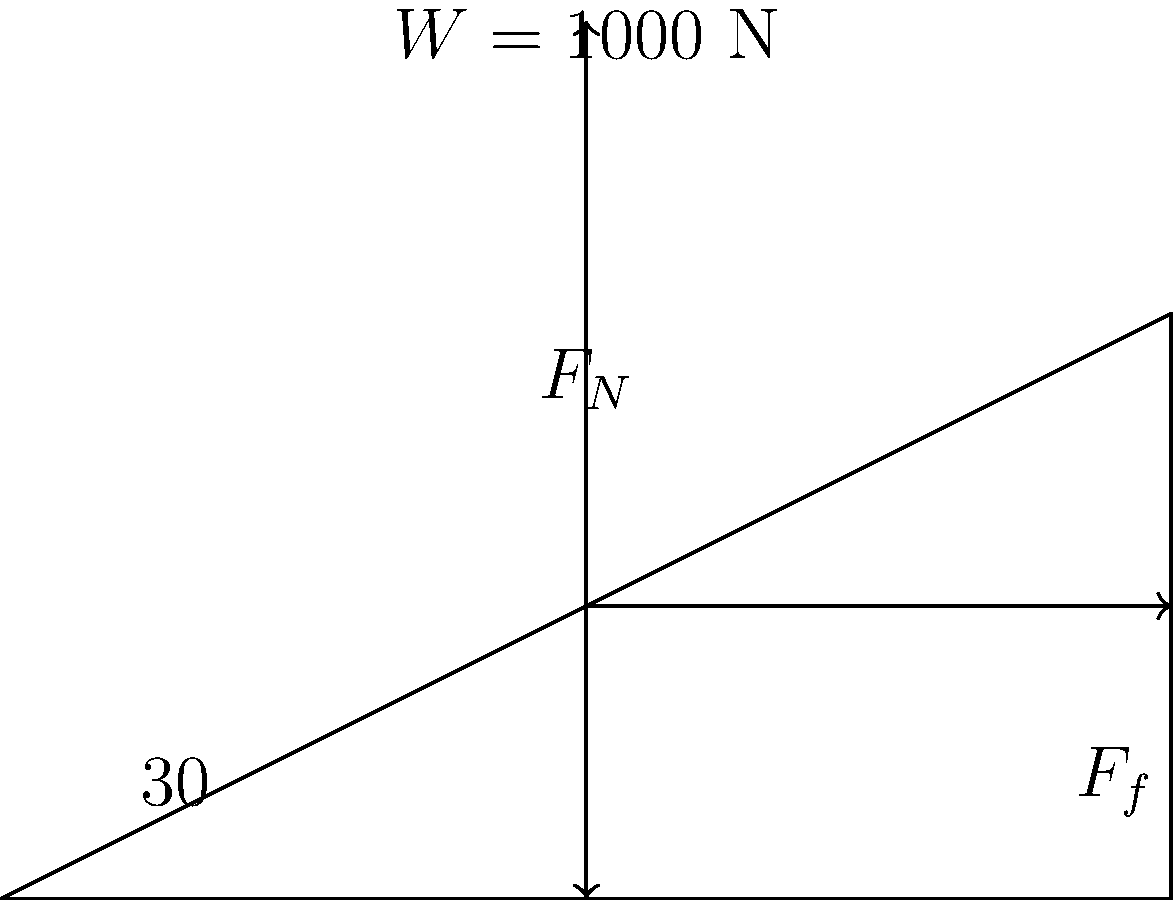As part of a community initiative to improve accessibility, you're analyzing the forces acting on a wheelchair as it moves up a ramp. The ramp has an angle of 30° with the horizontal, and the combined weight of the wheelchair and its occupant is 1000 N. If the coefficient of friction between the wheelchair wheels and the ramp surface is 0.2, calculate the magnitude of the force parallel to the ramp that needs to be applied to move the wheelchair up the ramp at a constant velocity. Let's approach this step-by-step:

1) First, we need to identify the forces acting on the wheelchair:
   - Weight (W) = 1000 N (acting vertically downward)
   - Normal force (F_N) (perpendicular to the ramp surface)
   - Friction force (F_f) (parallel to the ramp surface, opposing motion)
   - Applied force (F) (parallel to the ramp surface, in the direction of motion)

2) We can break down the weight into components parallel and perpendicular to the ramp:
   - Weight component parallel to ramp: $W \sin(30°) = 1000 \sin(30°) = 500$ N
   - Weight component perpendicular to ramp: $W \cos(30°) = 1000 \cos(30°) \approx 866$ N

3) The normal force (F_N) is equal to the weight component perpendicular to the ramp:
   $F_N = 866$ N

4) The friction force is given by $F_f = \mu F_N$, where $\mu$ is the coefficient of friction:
   $F_f = 0.2 * 866 = 173.2$ N

5) For constant velocity motion, the sum of forces parallel to the ramp must be zero:
   $F - F_f - W \sin(30°) = 0$

6) Substituting known values:
   $F - 173.2 - 500 = 0$

7) Solving for F:
   $F = 173.2 + 500 = 673.2$ N

Therefore, a force of approximately 673.2 N parallel to the ramp is needed to move the wheelchair up at constant velocity.
Answer: 673.2 N 